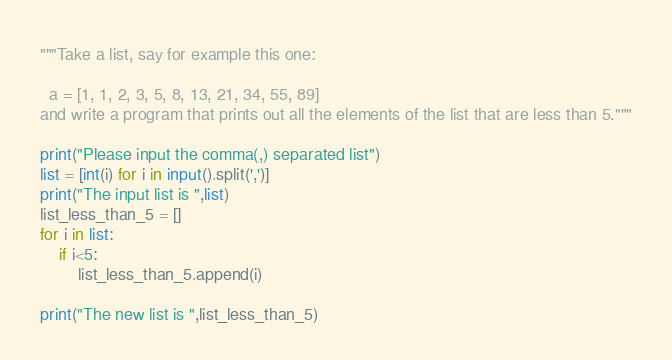Convert code to text. <code><loc_0><loc_0><loc_500><loc_500><_Python_>"""Take a list, say for example this one:

  a = [1, 1, 2, 3, 5, 8, 13, 21, 34, 55, 89]
and write a program that prints out all the elements of the list that are less than 5."""

print("Please input the comma(,) separated list")
list = [int(i) for i in input().split(',')]
print("The input list is ",list)
list_less_than_5 = []
for i in list:
    if i<5:
        list_less_than_5.append(i)

print("The new list is ",list_less_than_5)
</code> 